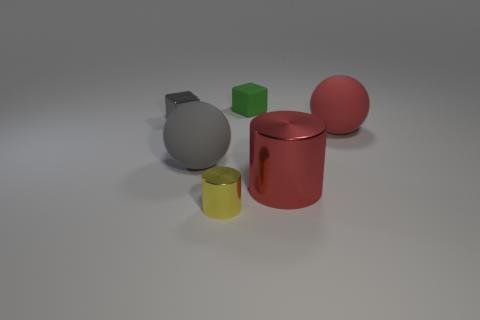Add 1 big red balls. How many objects exist? 7 Subtract 2 spheres. How many spheres are left? 0 Subtract all cyan cubes. Subtract all cyan cylinders. How many cubes are left? 2 Subtract all cyan spheres. How many green blocks are left? 1 Subtract all large gray matte objects. Subtract all tiny yellow things. How many objects are left? 4 Add 3 tiny yellow things. How many tiny yellow things are left? 4 Add 2 large gray rubber objects. How many large gray rubber objects exist? 3 Subtract all yellow cylinders. How many cylinders are left? 1 Subtract 1 green blocks. How many objects are left? 5 Subtract all cubes. How many objects are left? 4 